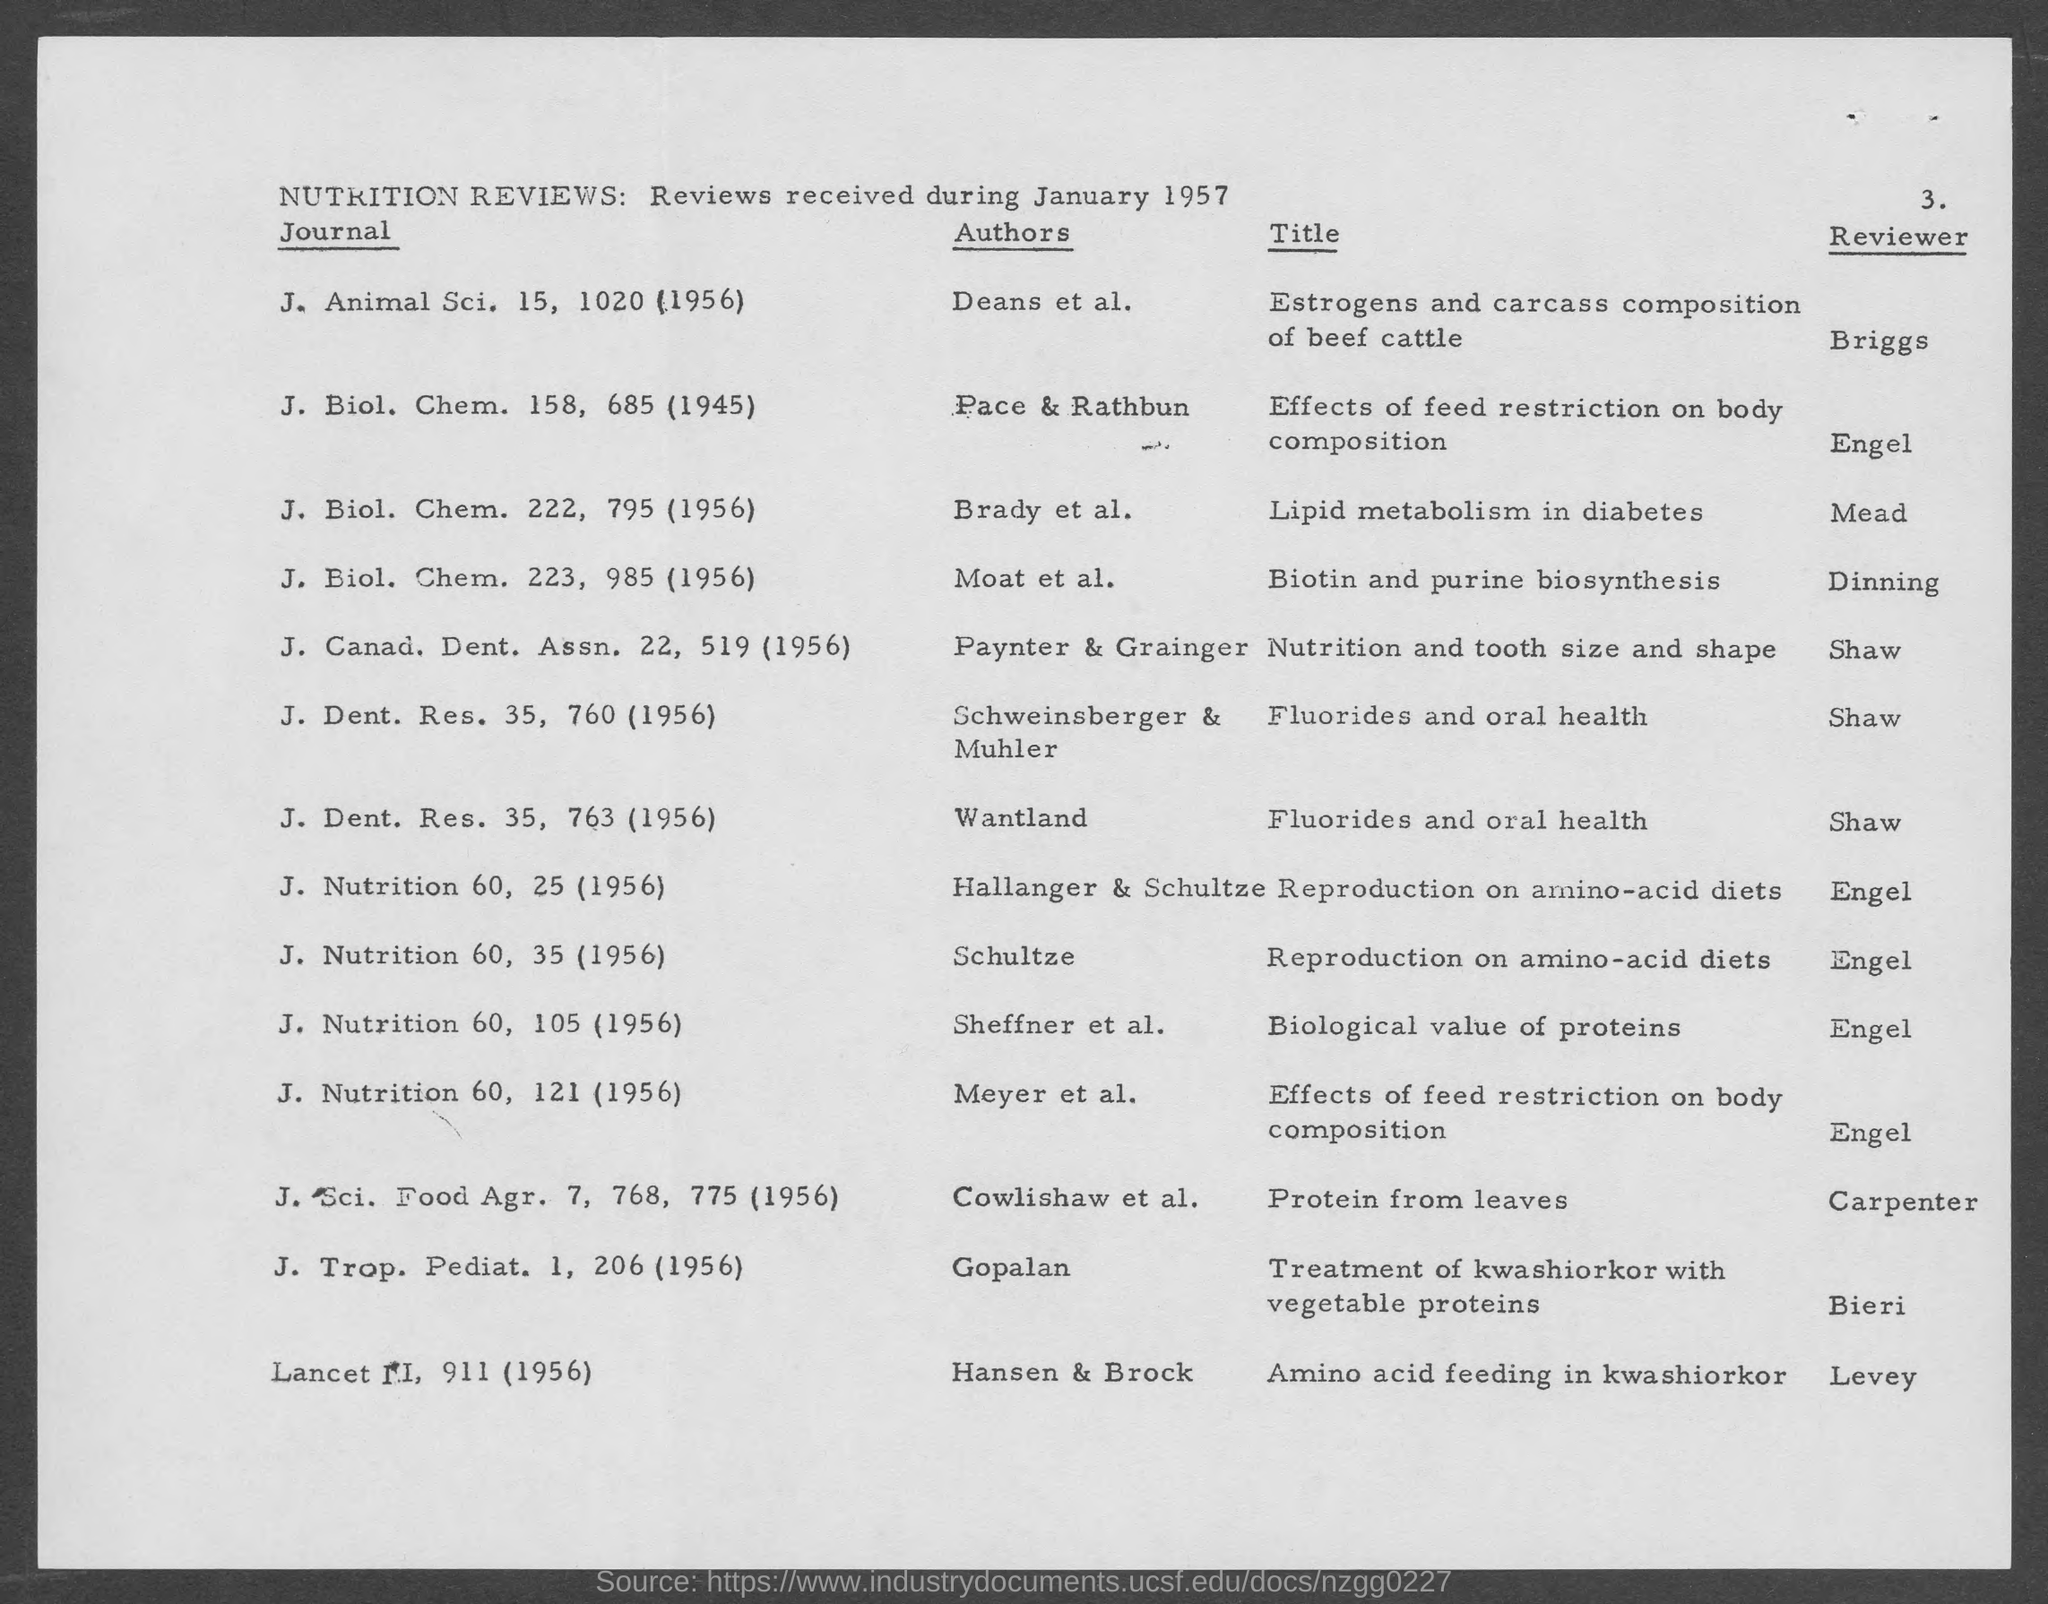Who is the reviewer of the journal J. Nutrition 60, 35 (1956)? The reviewer of the journal J. Nutrition 60, page 35 from the year 1956 is identified as Engel, according to the photographed document. 